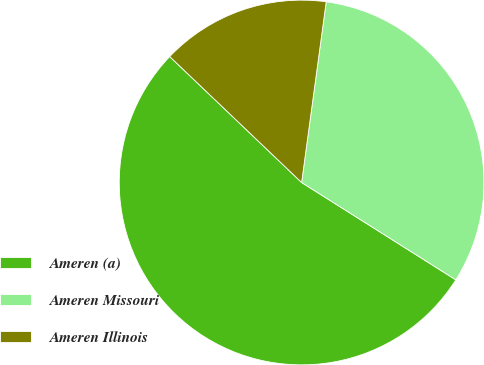<chart> <loc_0><loc_0><loc_500><loc_500><pie_chart><fcel>Ameren (a)<fcel>Ameren Missouri<fcel>Ameren Illinois<nl><fcel>53.17%<fcel>31.81%<fcel>15.02%<nl></chart> 